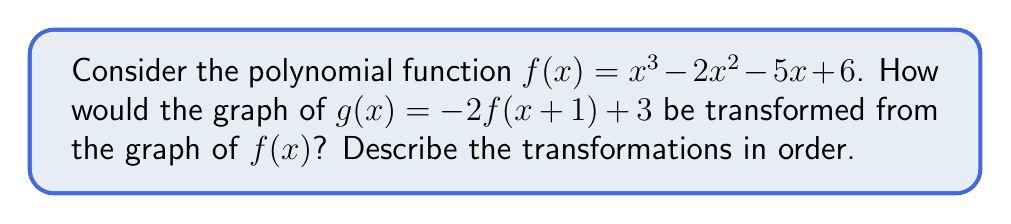Could you help me with this problem? Let's analyze the transformations step-by-step:

1) First, we start with $f(x) = x^3 - 2x^2 - 5x + 6$.

2) Inside the parentheses of $g(x)$, we see $(x+1)$. This means we shift the graph 1 unit to the left.
   $f(x+1) = (x+1)^3 - 2(x+1)^2 - 5(x+1) + 6$

3) Outside the parentheses, we see a factor of -2. This means we reflect the graph over the x-axis and stretch it vertically by a factor of 2.
   $-2f(x+1) = -2[(x+1)^3 - 2(x+1)^2 - 5(x+1) + 6]$

4) Finally, we add 3 to the entire function. This shifts the graph up 3 units.
   $g(x) = -2f(x+1) + 3$

Therefore, the transformations in order are:
a) Shift 1 unit left
b) Reflect over the x-axis
c) Stretch vertically by a factor of 2
d) Shift 3 units up
Answer: Left 1, reflect over x-axis, stretch vertically by 2, up 3 